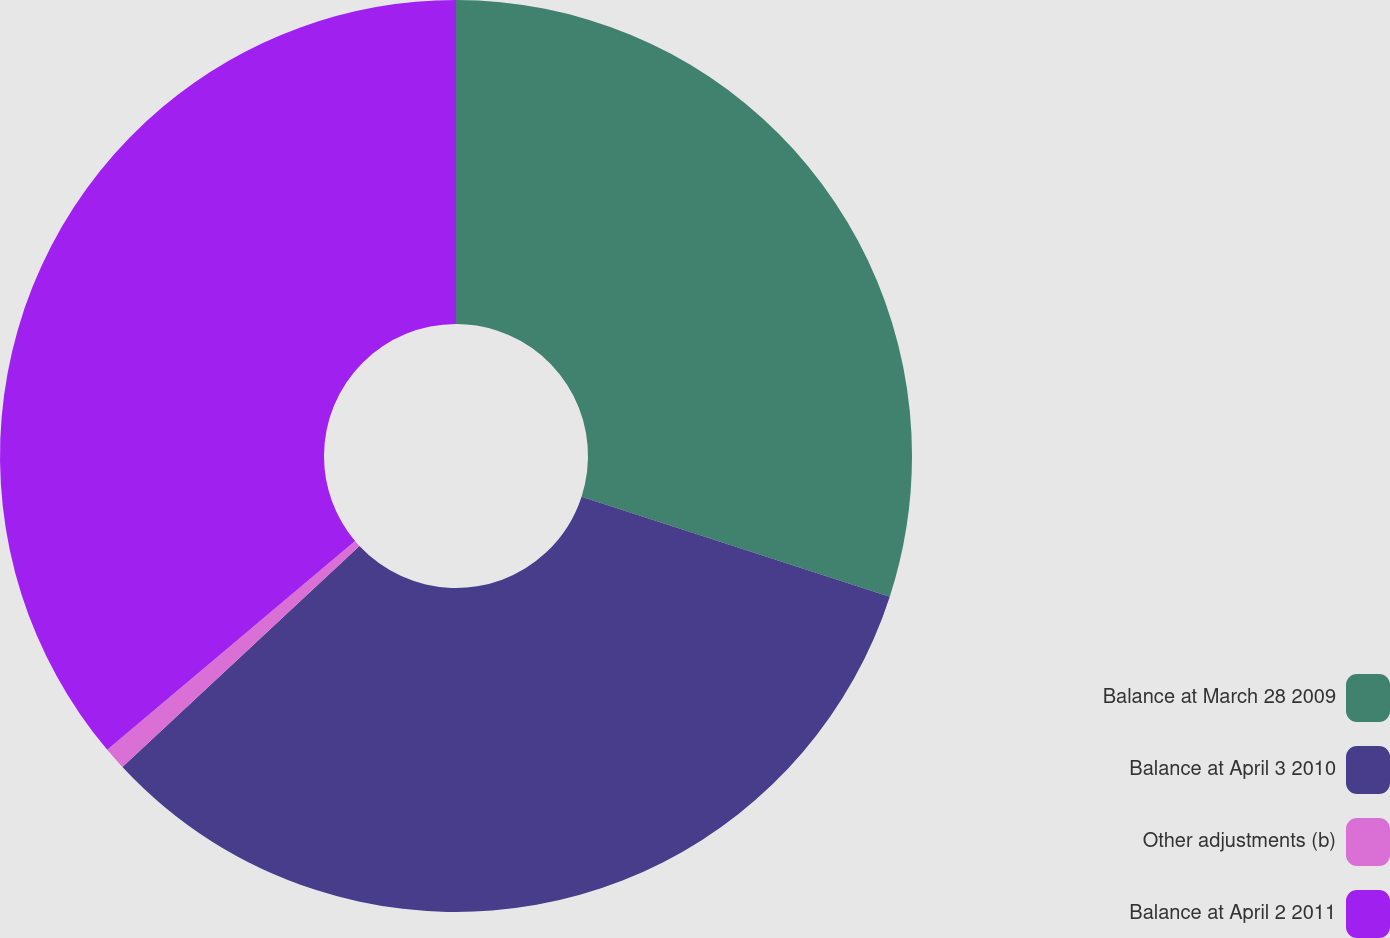Convert chart to OTSL. <chart><loc_0><loc_0><loc_500><loc_500><pie_chart><fcel>Balance at March 28 2009<fcel>Balance at April 3 2010<fcel>Other adjustments (b)<fcel>Balance at April 2 2011<nl><fcel>29.99%<fcel>33.07%<fcel>0.8%<fcel>36.14%<nl></chart> 